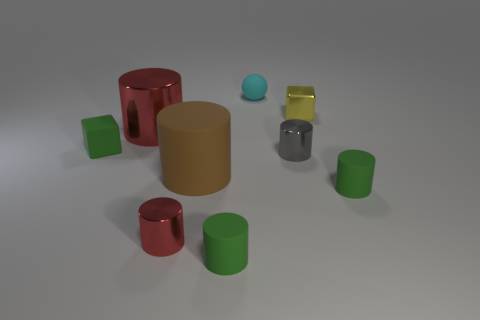Subtract all large red cylinders. How many cylinders are left? 5 Subtract 1 blocks. How many blocks are left? 1 Subtract all brown cylinders. How many cylinders are left? 5 Subtract 0 cyan cylinders. How many objects are left? 9 Subtract all spheres. How many objects are left? 8 Subtract all green cylinders. Subtract all red balls. How many cylinders are left? 4 Subtract all purple balls. How many cyan cylinders are left? 0 Subtract all tiny purple metal objects. Subtract all yellow metallic objects. How many objects are left? 8 Add 1 green matte blocks. How many green matte blocks are left? 2 Add 8 spheres. How many spheres exist? 9 